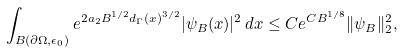<formula> <loc_0><loc_0><loc_500><loc_500>\int _ { B ( \partial \Omega , \epsilon _ { 0 } ) } e ^ { 2 a _ { 2 } B ^ { 1 / 2 } d _ { \Gamma } ( x ) ^ { 3 / 2 } } | \psi _ { B } ( x ) | ^ { 2 } \, d x \leq C e ^ { C B ^ { 1 / 8 } } \| \psi _ { B } \| _ { 2 } ^ { 2 } ,</formula> 